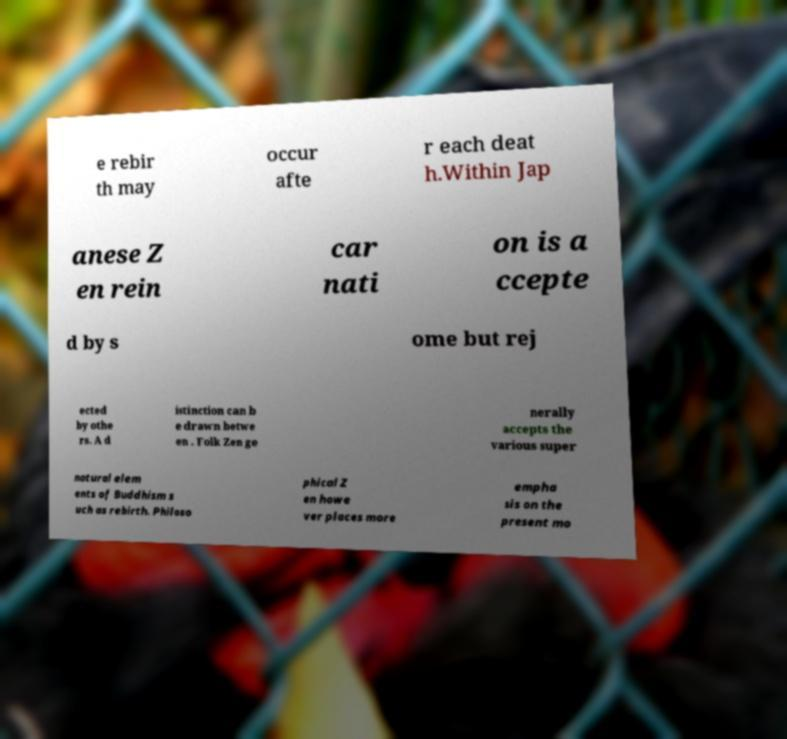Can you accurately transcribe the text from the provided image for me? e rebir th may occur afte r each deat h.Within Jap anese Z en rein car nati on is a ccepte d by s ome but rej ected by othe rs. A d istinction can b e drawn betwe en . Folk Zen ge nerally accepts the various super natural elem ents of Buddhism s uch as rebirth. Philoso phical Z en howe ver places more empha sis on the present mo 